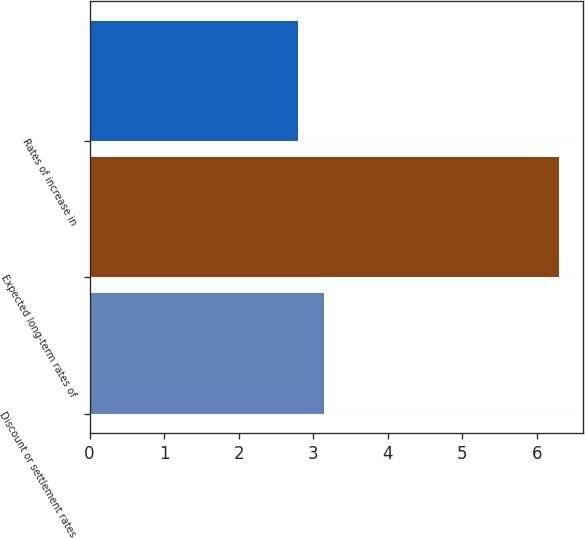Convert chart. <chart><loc_0><loc_0><loc_500><loc_500><bar_chart><fcel>Discount or settlement rates<fcel>Expected long-term rates of<fcel>Rates of increase in<nl><fcel>3.15<fcel>6.3<fcel>2.8<nl></chart> 